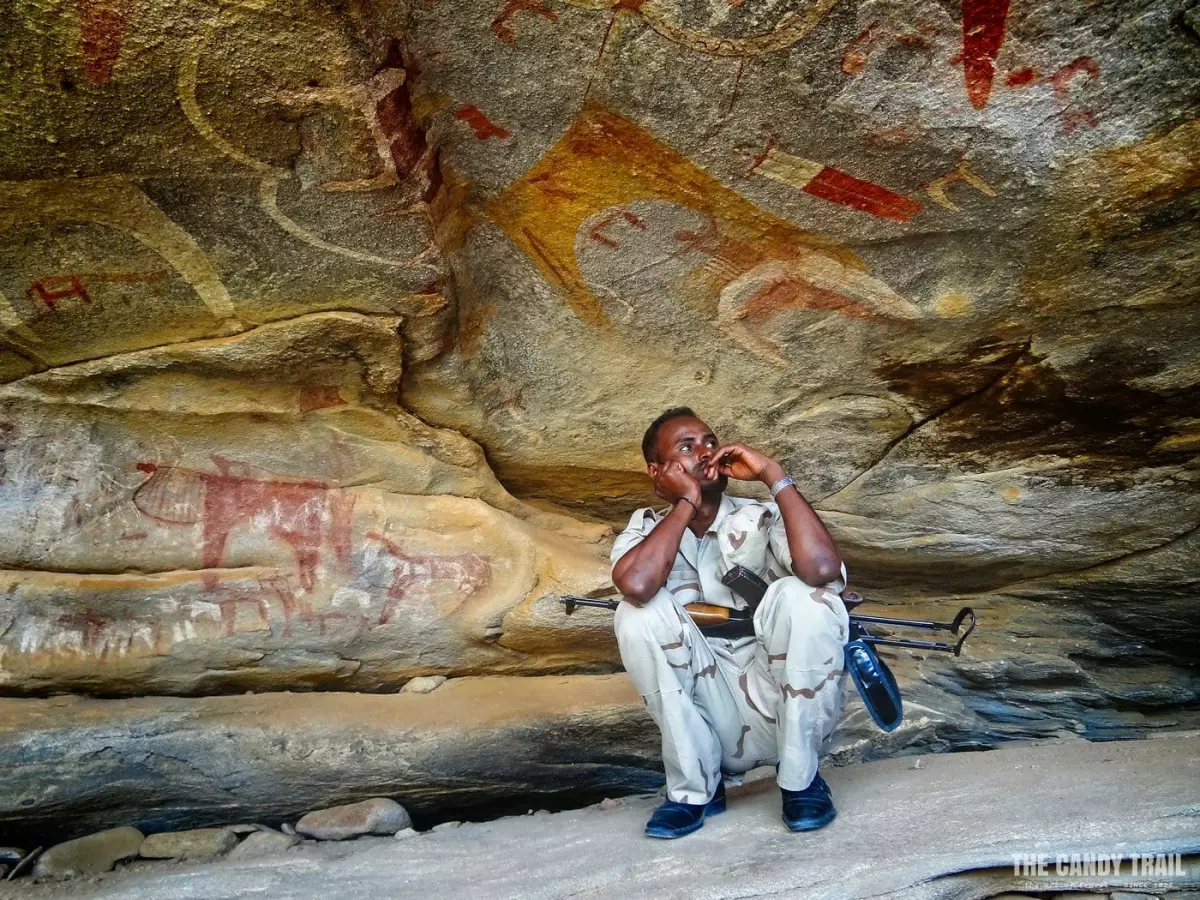What do you see happening in this image? The photograph captures a poignant moment in the historical cave of Laas Geel in Somaliland, known for its ancient rock paintings. In the image, a man wearing a white shirt and khaki pants sits pensively while holding a rifle. He seems to be contemplating the cave's prehistoric artwork, vividly painted in red, portraying both animals and human figures. This setting tells a story of cultural heritage juxtaposed with modern human presence, reflecting on past civilizations through the silent dialogue between the man and the cave paintings. 